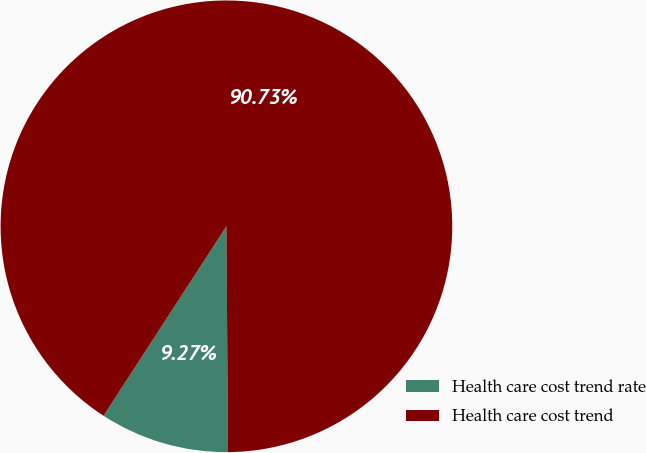Convert chart to OTSL. <chart><loc_0><loc_0><loc_500><loc_500><pie_chart><fcel>Health care cost trend rate<fcel>Health care cost trend<nl><fcel>9.27%<fcel>90.73%<nl></chart> 